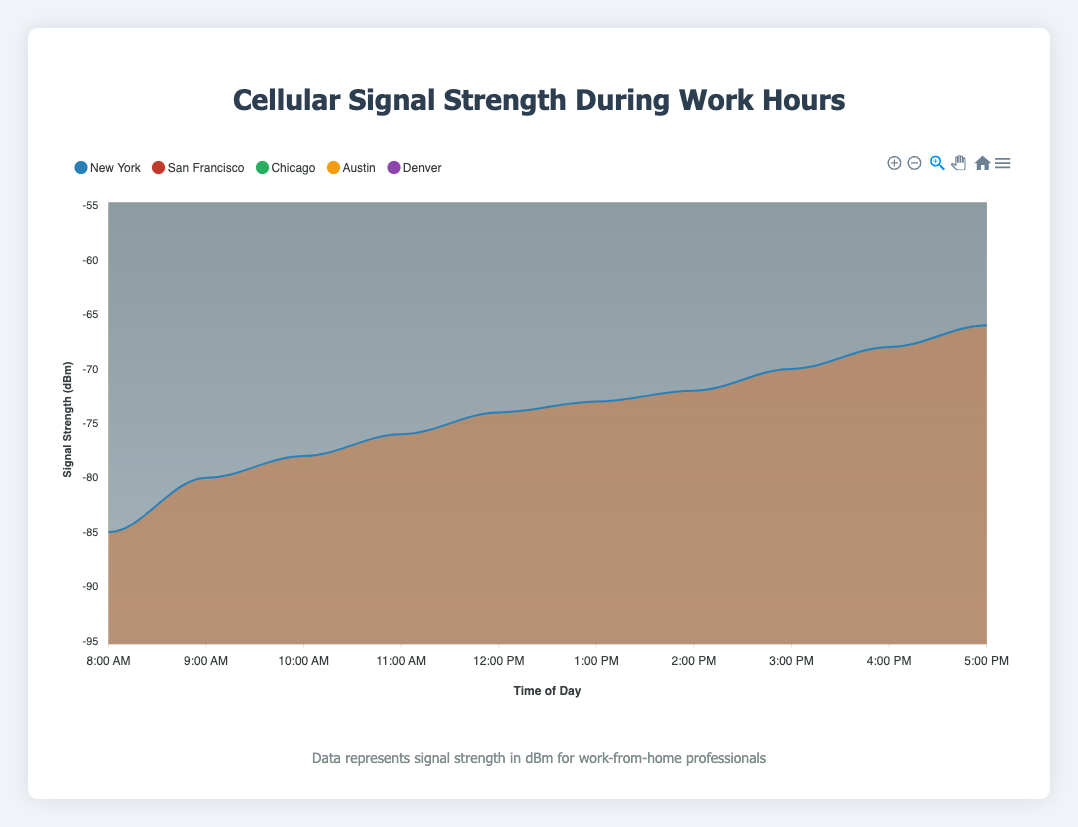What is the title of the chart? The title is typically displayed at the top of the chart and summarizes what the chart represents. Here, the title displayed at the top is "Cellular Signal Strength During Work Hours".
Answer: Cellular Signal Strength During Work Hours Which location has the strongest signal at 1:00 PM? To find the strongest signal, look for the highest value (least negative) at 1:00 PM. Austin has the value of -67 dBm, which is the highest among other locations.
Answer: Austin At what time does San Francisco show the weakest signal? The weakest signal for San Francisco can be found by identifying the lowest data point in the San Francisco series. The weakest signal is -90 dBm at 8:00 AM.
Answer: 8:00 AM What is the range of signal strength for New York throughout the day? The range is the difference between the maximum and minimum values. New York's signal ranges from -66 dBm at 5:00 PM to -85 dBm at 8:00 AM. The range is 66 - 85 = 19 dBm.
Answer: 19 dBm How does the signal strength in Austin change from 8:00 AM to 5:00 PM? Observe the trend line for Austin from 8:00 AM to 5:00 PM. The signal strength improves from -75 dBm to -60 dBm.
Answer: Improves Which city shows the most consistent signal strength throughout the day? Consistency can be judged by the smallest changes in signal strength. Denver shows relatively small fluctuations between -85 dBm to -69 dBm compared to other cities.
Answer: Denver Between 10:00 AM and 3:00 PM, which city experienced the largest improvement in signal strength? Calculate the change in signal strength from 10:00 AM to 3:00 PM for each city. Austin improved from -72 dBm to -63 dBm, an improvement of 9 dBm, which is the largest among the cities.
Answer: Austin What is the average signal strength in Chicago at 12:00 PM and 1:00 PM? Calculate the average by summing the values at 12:00 PM and 1:00 PM for Chicago and dividing by 2. (-73 + -72) / 2 = -72.5 dBm.
Answer: -72.5 dBm Which city shows a signal strength of -80 dBm at any time during the day? Look through the data points to find where -80 dBm occurs. Chicago shows -80 dBm at 8:00 AM.
Answer: Chicago Is there any time when Austin's signal is weaker than Denver's signal? Compare the signal strength of Austin and Denver throughout the day. There is no time when Austin's signal is weaker (more negative) than Denver's signal.
Answer: No 